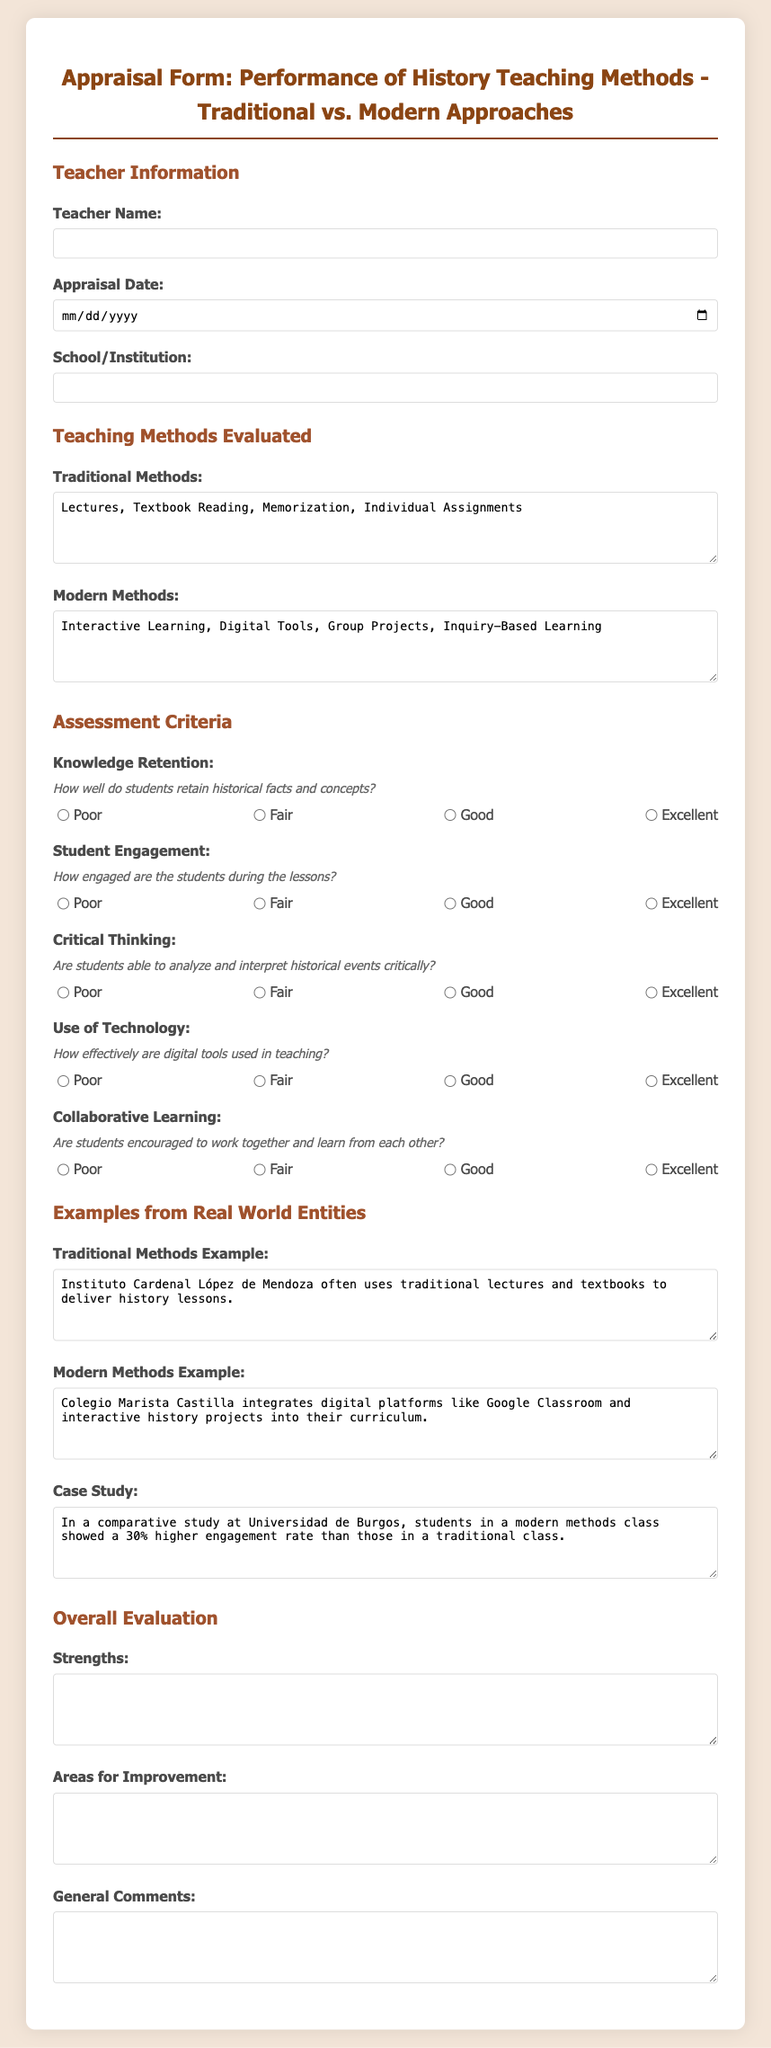What is the title of the appraisal form? The title is found at the top of the document, which provides a clear label for the content.
Answer: Appraisal Form: Performance of History Teaching Methods - Traditional vs. Modern Approaches What are the traditional methods listed in the form? The traditional methods can be found in the designated textarea area under the teaching methods evaluated section.
Answer: Lectures, Textbook Reading, Memorization, Individual Assignments What is the date format for the appraisal date? The format for the appraisal date input in the document specifies how the user should fill it out.
Answer: YYYY-MM-DD Which school is mentioned as using modern methods? The example for modern methods provides specific information about a school implementing modern teaching techniques.
Answer: Colegio Marista Castilla How much higher was the engagement rate in the modern methods class compared to the traditional class? The percentage difference is specified in the case study portion of the document, indicating the improvement seen.
Answer: 30% What is the first criterion for assessment listed in the document? The criteria are organized sequentially, making it straightforward to identify the first one.
Answer: Knowledge Retention What is the description associated with the "Use of Technology" assessment criterion? Each criterion has an accompanying description that clarifies what aspect is being evaluated, found in the document.
Answer: How effectively are digital tools used in teaching? What are the strengths and areas for improvement sections intended for? These sections are meant to provide feedback on the teaching methods evaluated, indicating their purpose.
Answer: Feedback and evaluation insights What is the name of the case study institution? The case study mentions a specific university that conducted the comparison of teaching methods.
Answer: Universidad de Burgos 